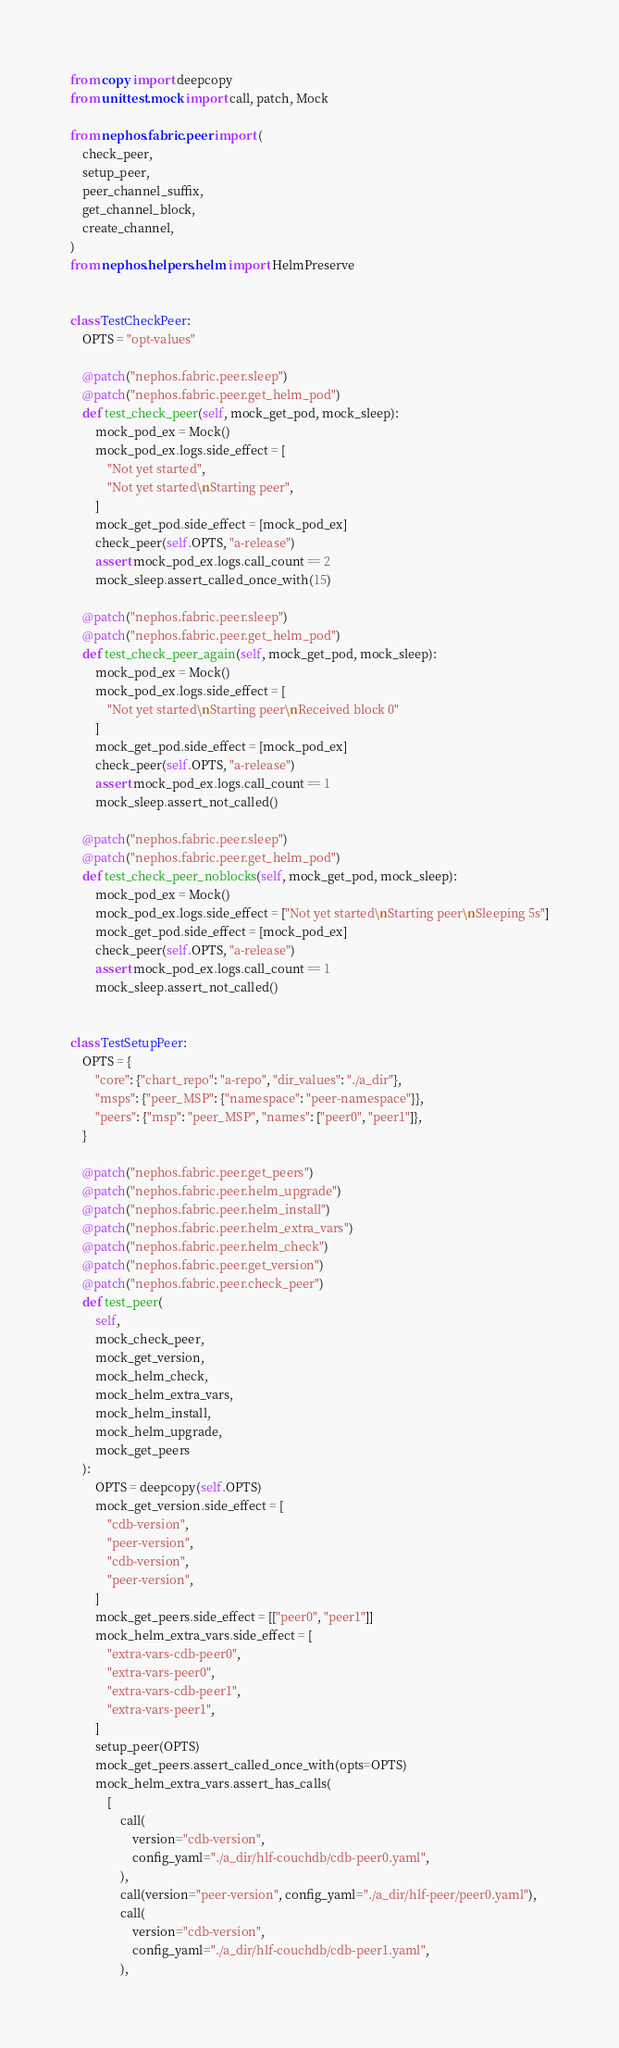Convert code to text. <code><loc_0><loc_0><loc_500><loc_500><_Python_>from copy import deepcopy
from unittest.mock import call, patch, Mock

from nephos.fabric.peer import (
    check_peer,
    setup_peer,
    peer_channel_suffix,
    get_channel_block,
    create_channel,
)
from nephos.helpers.helm import HelmPreserve


class TestCheckPeer:
    OPTS = "opt-values"

    @patch("nephos.fabric.peer.sleep")
    @patch("nephos.fabric.peer.get_helm_pod")
    def test_check_peer(self, mock_get_pod, mock_sleep):
        mock_pod_ex = Mock()
        mock_pod_ex.logs.side_effect = [
            "Not yet started",
            "Not yet started\nStarting peer",
        ]
        mock_get_pod.side_effect = [mock_pod_ex]
        check_peer(self.OPTS, "a-release")
        assert mock_pod_ex.logs.call_count == 2
        mock_sleep.assert_called_once_with(15)

    @patch("nephos.fabric.peer.sleep")
    @patch("nephos.fabric.peer.get_helm_pod")
    def test_check_peer_again(self, mock_get_pod, mock_sleep):
        mock_pod_ex = Mock()
        mock_pod_ex.logs.side_effect = [
            "Not yet started\nStarting peer\nReceived block 0"
        ]
        mock_get_pod.side_effect = [mock_pod_ex]
        check_peer(self.OPTS, "a-release")
        assert mock_pod_ex.logs.call_count == 1
        mock_sleep.assert_not_called()

    @patch("nephos.fabric.peer.sleep")
    @patch("nephos.fabric.peer.get_helm_pod")
    def test_check_peer_noblocks(self, mock_get_pod, mock_sleep):
        mock_pod_ex = Mock()
        mock_pod_ex.logs.side_effect = ["Not yet started\nStarting peer\nSleeping 5s"]
        mock_get_pod.side_effect = [mock_pod_ex]
        check_peer(self.OPTS, "a-release")
        assert mock_pod_ex.logs.call_count == 1
        mock_sleep.assert_not_called()


class TestSetupPeer:
    OPTS = {
        "core": {"chart_repo": "a-repo", "dir_values": "./a_dir"},
        "msps": {"peer_MSP": {"namespace": "peer-namespace"}},
        "peers": {"msp": "peer_MSP", "names": ["peer0", "peer1"]},
    }

    @patch("nephos.fabric.peer.get_peers")
    @patch("nephos.fabric.peer.helm_upgrade")
    @patch("nephos.fabric.peer.helm_install")
    @patch("nephos.fabric.peer.helm_extra_vars")
    @patch("nephos.fabric.peer.helm_check")
    @patch("nephos.fabric.peer.get_version")
    @patch("nephos.fabric.peer.check_peer")
    def test_peer(
        self,
        mock_check_peer,
        mock_get_version,
        mock_helm_check,
        mock_helm_extra_vars,
        mock_helm_install,
        mock_helm_upgrade,
        mock_get_peers
    ):
        OPTS = deepcopy(self.OPTS)
        mock_get_version.side_effect = [
            "cdb-version",
            "peer-version",
            "cdb-version",
            "peer-version",
        ]
        mock_get_peers.side_effect = [["peer0", "peer1"]]
        mock_helm_extra_vars.side_effect = [
            "extra-vars-cdb-peer0",
            "extra-vars-peer0",
            "extra-vars-cdb-peer1",
            "extra-vars-peer1",
        ]
        setup_peer(OPTS)
        mock_get_peers.assert_called_once_with(opts=OPTS)
        mock_helm_extra_vars.assert_has_calls(
            [
                call(
                    version="cdb-version",
                    config_yaml="./a_dir/hlf-couchdb/cdb-peer0.yaml",
                ),
                call(version="peer-version", config_yaml="./a_dir/hlf-peer/peer0.yaml"),
                call(
                    version="cdb-version",
                    config_yaml="./a_dir/hlf-couchdb/cdb-peer1.yaml",
                ),</code> 